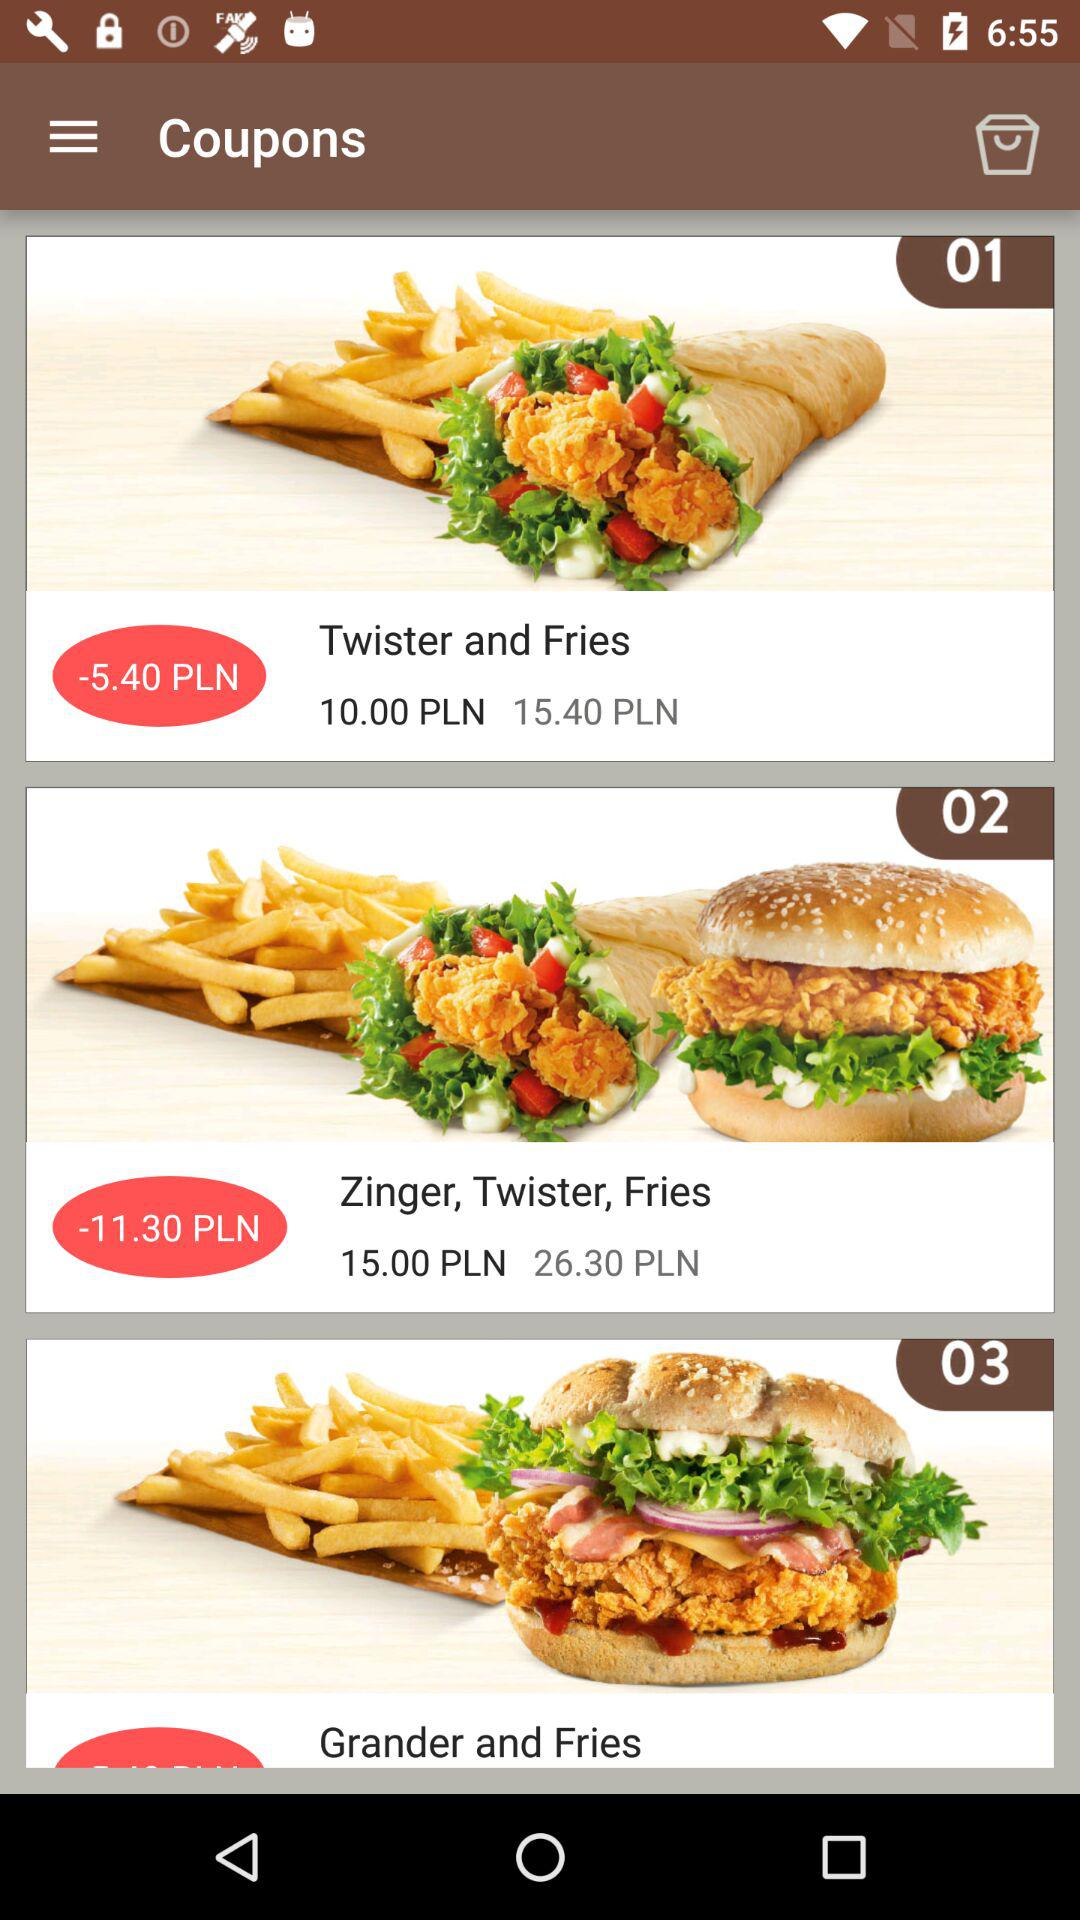Which item has the highest price?
Answer the question using a single word or phrase. Zinger, Twister, Fries 